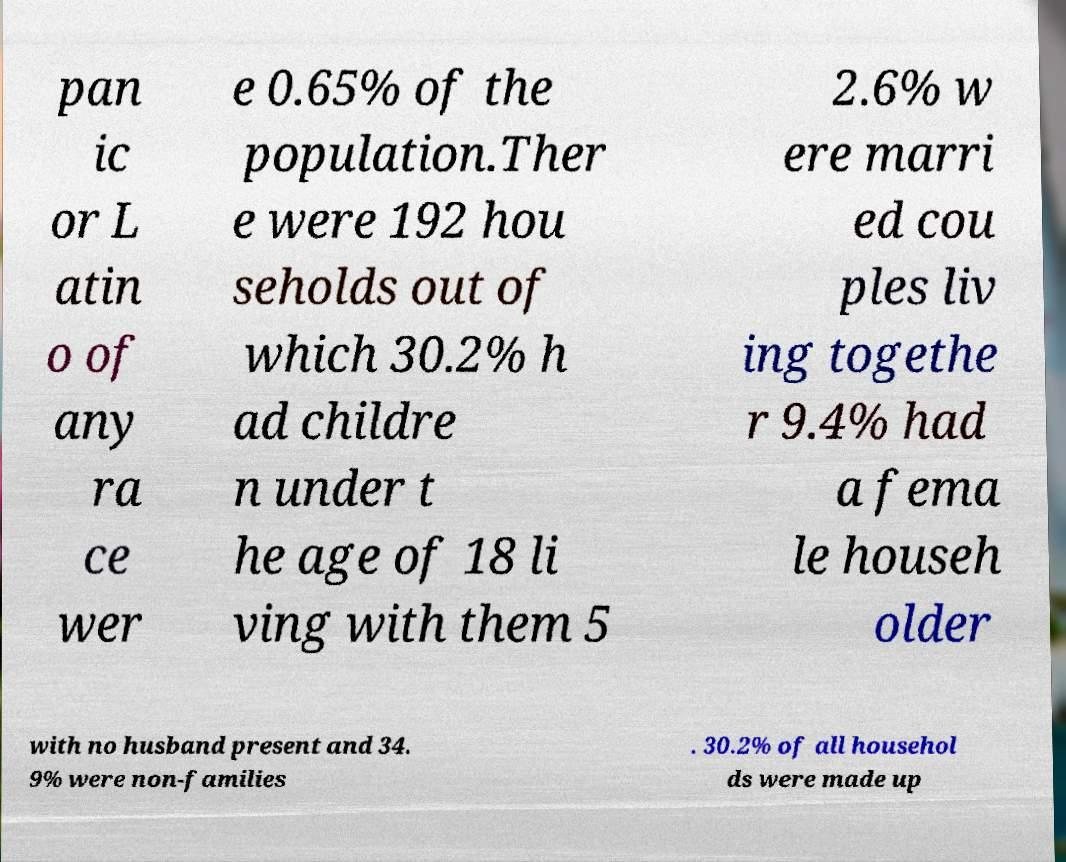Can you read and provide the text displayed in the image?This photo seems to have some interesting text. Can you extract and type it out for me? pan ic or L atin o of any ra ce wer e 0.65% of the population.Ther e were 192 hou seholds out of which 30.2% h ad childre n under t he age of 18 li ving with them 5 2.6% w ere marri ed cou ples liv ing togethe r 9.4% had a fema le househ older with no husband present and 34. 9% were non-families . 30.2% of all househol ds were made up 